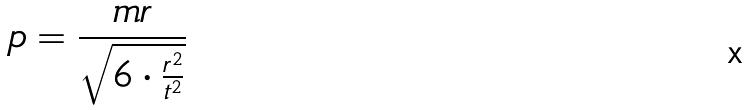<formula> <loc_0><loc_0><loc_500><loc_500>p = \frac { m r } { \sqrt { 6 \cdot \frac { r ^ { 2 } } { t ^ { 2 } } } }</formula> 